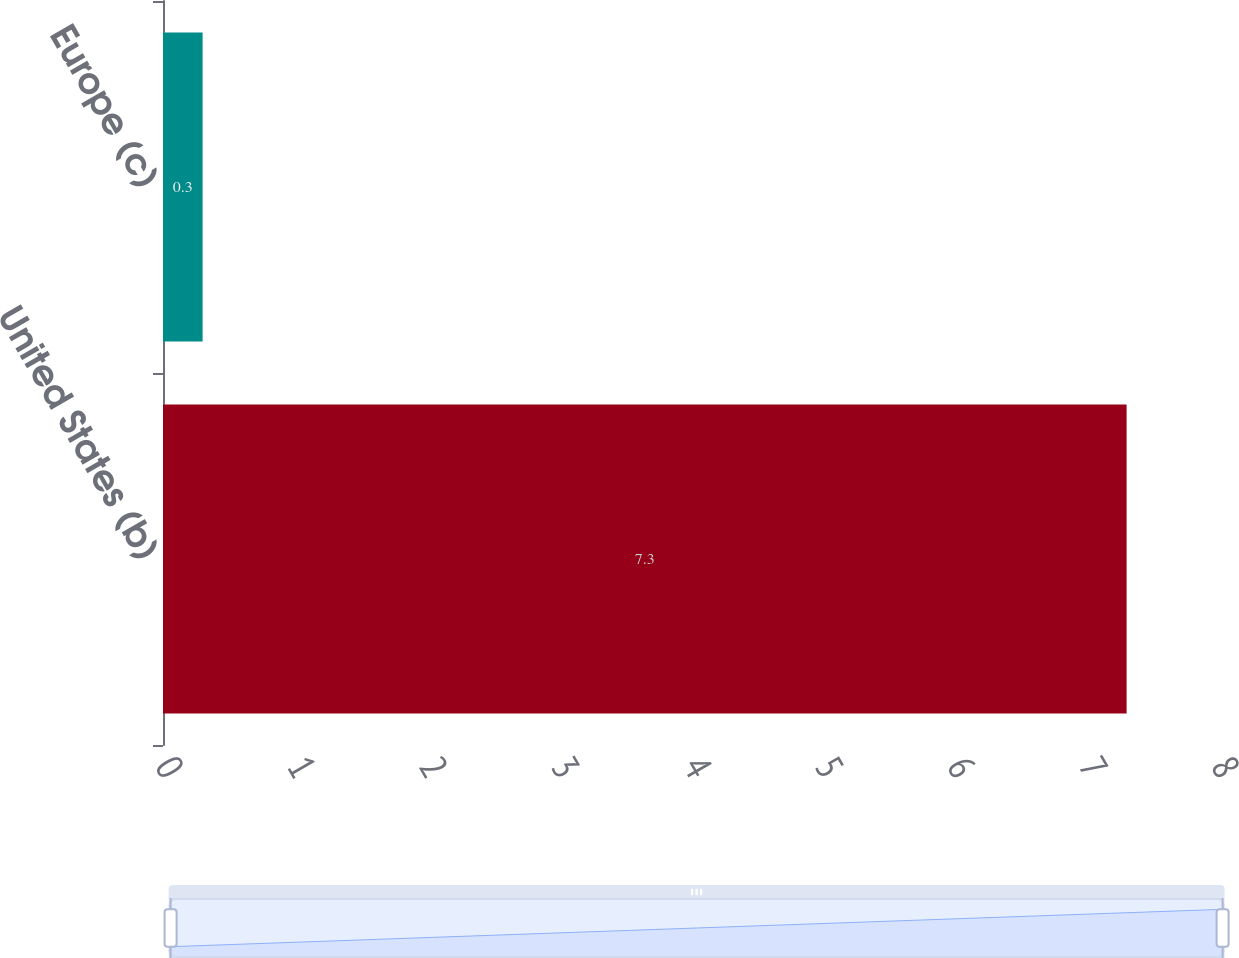Convert chart. <chart><loc_0><loc_0><loc_500><loc_500><bar_chart><fcel>United States (b)<fcel>Europe (c)<nl><fcel>7.3<fcel>0.3<nl></chart> 